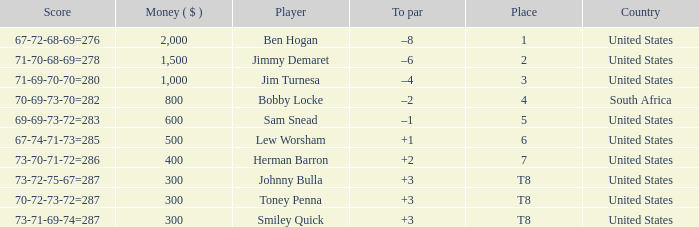In which spot is a player with earnings exceeding 300 and a combined score of 71-69-70-70, which amounts to 280? 3.0. 